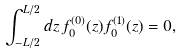<formula> <loc_0><loc_0><loc_500><loc_500>\int _ { - L / 2 } ^ { L / 2 } d z \, f _ { 0 } ^ { ( 0 ) } ( z ) f _ { 0 } ^ { ( 1 ) } ( z ) = 0 ,</formula> 